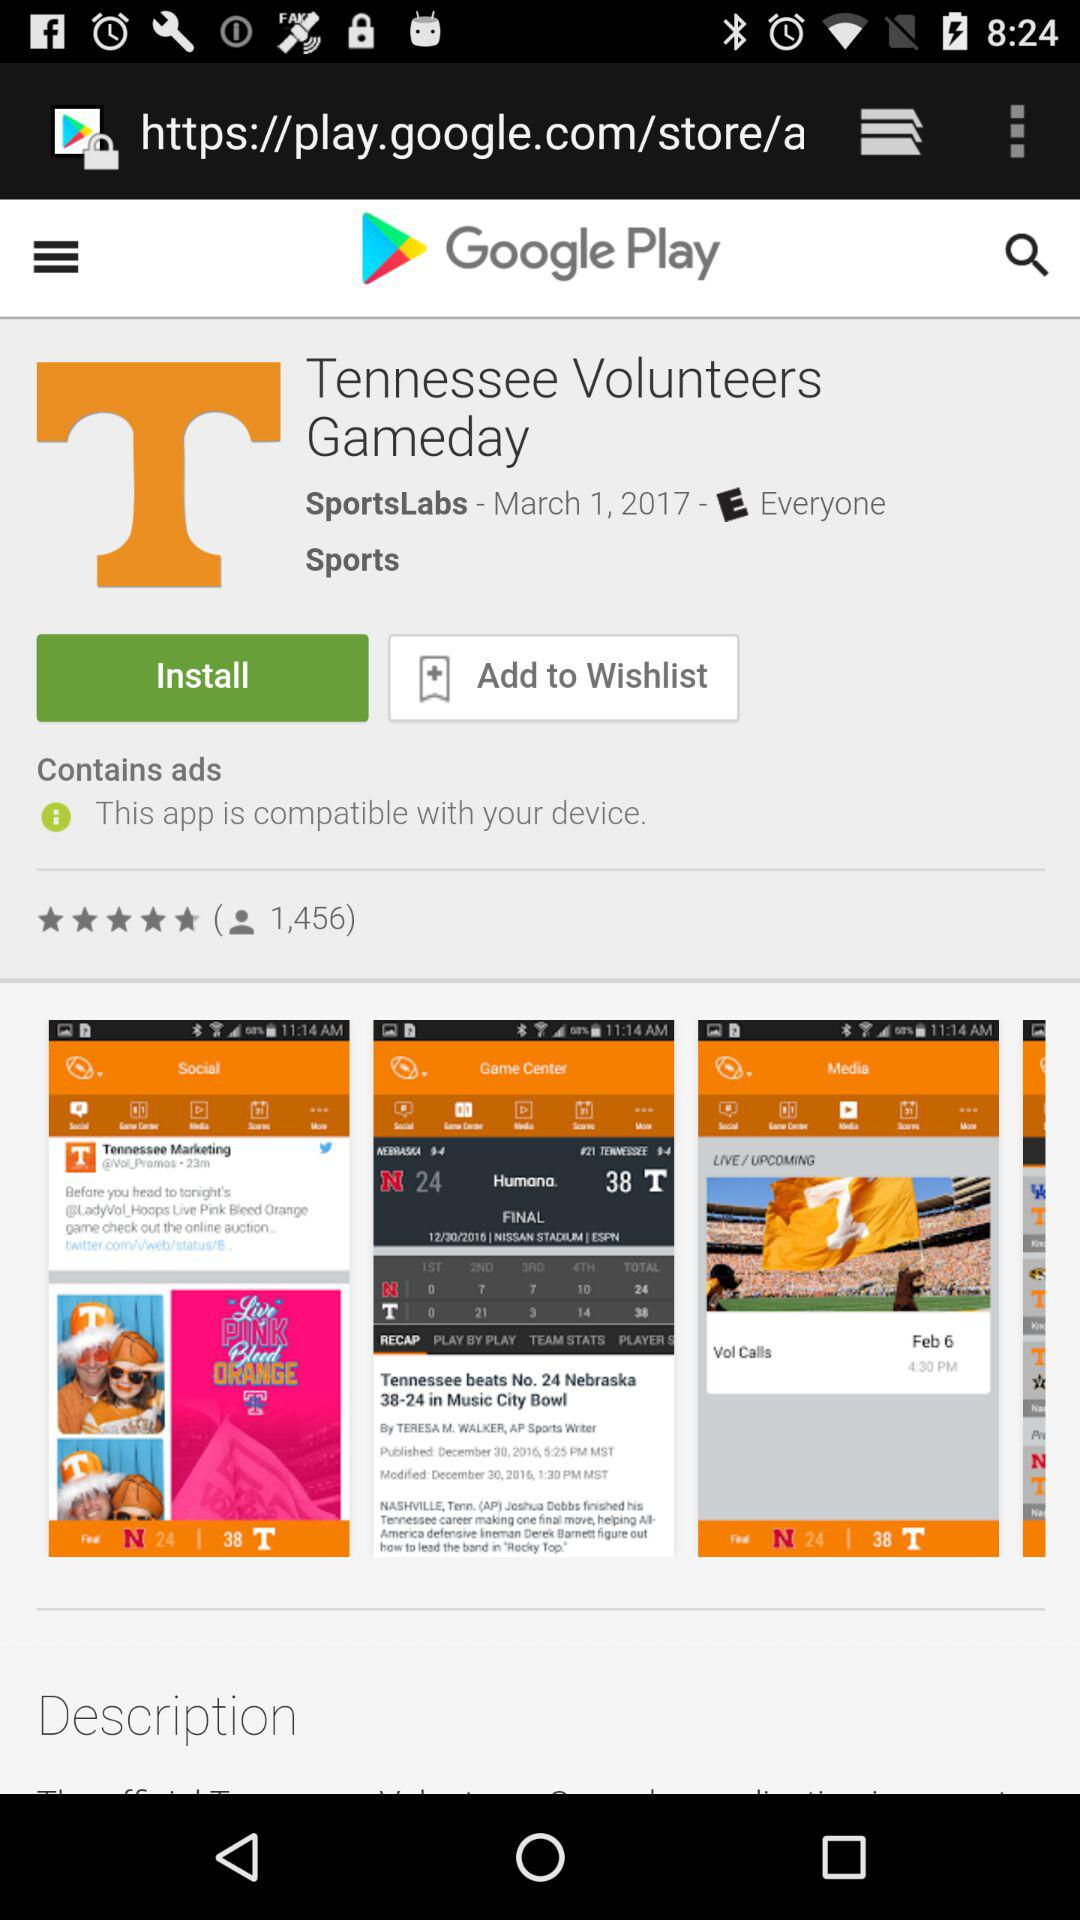What is the rating? The rating is 4.8 stars. 